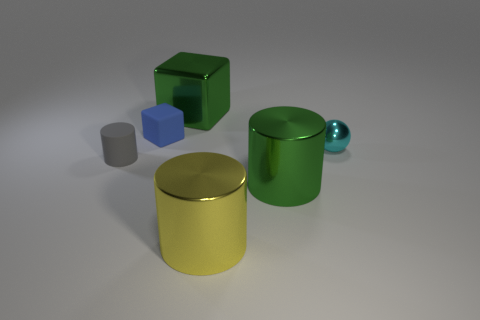Add 3 tiny balls. How many objects exist? 9 Subtract all balls. How many objects are left? 5 Subtract all small gray matte things. Subtract all small cyan spheres. How many objects are left? 4 Add 3 tiny cyan things. How many tiny cyan things are left? 4 Add 5 yellow things. How many yellow things exist? 6 Subtract 1 gray cylinders. How many objects are left? 5 